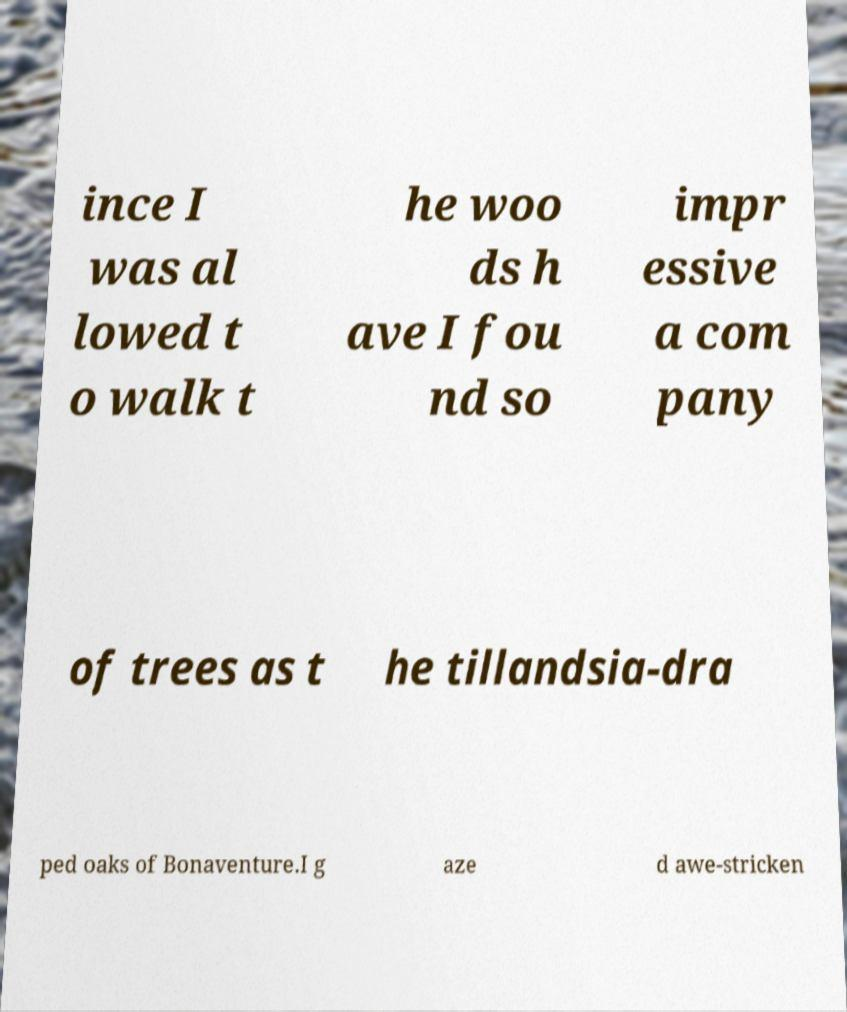Can you accurately transcribe the text from the provided image for me? ince I was al lowed t o walk t he woo ds h ave I fou nd so impr essive a com pany of trees as t he tillandsia-dra ped oaks of Bonaventure.I g aze d awe-stricken 